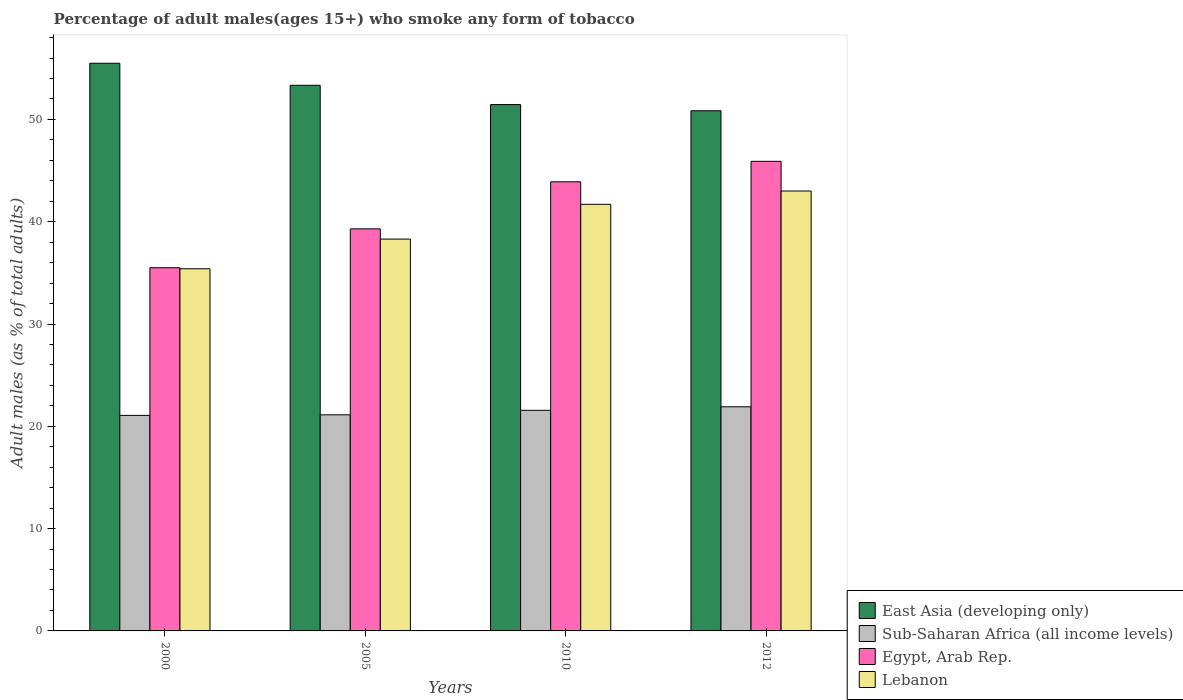How many different coloured bars are there?
Keep it short and to the point. 4. Are the number of bars per tick equal to the number of legend labels?
Offer a very short reply. Yes. How many bars are there on the 2nd tick from the left?
Offer a terse response. 4. How many bars are there on the 1st tick from the right?
Make the answer very short. 4. What is the label of the 4th group of bars from the left?
Make the answer very short. 2012. What is the percentage of adult males who smoke in East Asia (developing only) in 2010?
Provide a succinct answer. 51.45. Across all years, what is the maximum percentage of adult males who smoke in Egypt, Arab Rep.?
Give a very brief answer. 45.9. Across all years, what is the minimum percentage of adult males who smoke in East Asia (developing only)?
Offer a very short reply. 50.84. What is the total percentage of adult males who smoke in Sub-Saharan Africa (all income levels) in the graph?
Give a very brief answer. 85.66. What is the difference between the percentage of adult males who smoke in Egypt, Arab Rep. in 2005 and that in 2012?
Provide a short and direct response. -6.6. What is the difference between the percentage of adult males who smoke in Sub-Saharan Africa (all income levels) in 2010 and the percentage of adult males who smoke in East Asia (developing only) in 2012?
Provide a short and direct response. -29.28. What is the average percentage of adult males who smoke in Sub-Saharan Africa (all income levels) per year?
Provide a short and direct response. 21.42. In the year 2000, what is the difference between the percentage of adult males who smoke in Lebanon and percentage of adult males who smoke in Egypt, Arab Rep.?
Provide a short and direct response. -0.1. In how many years, is the percentage of adult males who smoke in East Asia (developing only) greater than 2 %?
Give a very brief answer. 4. What is the ratio of the percentage of adult males who smoke in Egypt, Arab Rep. in 2010 to that in 2012?
Your answer should be very brief. 0.96. Is the percentage of adult males who smoke in Lebanon in 2000 less than that in 2012?
Keep it short and to the point. Yes. Is the difference between the percentage of adult males who smoke in Lebanon in 2000 and 2012 greater than the difference between the percentage of adult males who smoke in Egypt, Arab Rep. in 2000 and 2012?
Offer a terse response. Yes. What is the difference between the highest and the second highest percentage of adult males who smoke in Egypt, Arab Rep.?
Your answer should be very brief. 2. What is the difference between the highest and the lowest percentage of adult males who smoke in Sub-Saharan Africa (all income levels)?
Your answer should be very brief. 0.84. Is the sum of the percentage of adult males who smoke in Egypt, Arab Rep. in 2000 and 2012 greater than the maximum percentage of adult males who smoke in Lebanon across all years?
Provide a succinct answer. Yes. What does the 1st bar from the left in 2010 represents?
Provide a short and direct response. East Asia (developing only). What does the 3rd bar from the right in 2005 represents?
Keep it short and to the point. Sub-Saharan Africa (all income levels). Is it the case that in every year, the sum of the percentage of adult males who smoke in East Asia (developing only) and percentage of adult males who smoke in Lebanon is greater than the percentage of adult males who smoke in Egypt, Arab Rep.?
Make the answer very short. Yes. Are all the bars in the graph horizontal?
Offer a terse response. No. What is the difference between two consecutive major ticks on the Y-axis?
Give a very brief answer. 10. Does the graph contain any zero values?
Give a very brief answer. No. Does the graph contain grids?
Provide a succinct answer. No. How many legend labels are there?
Offer a very short reply. 4. What is the title of the graph?
Make the answer very short. Percentage of adult males(ages 15+) who smoke any form of tobacco. What is the label or title of the X-axis?
Your response must be concise. Years. What is the label or title of the Y-axis?
Offer a terse response. Adult males (as % of total adults). What is the Adult males (as % of total adults) in East Asia (developing only) in 2000?
Your answer should be compact. 55.49. What is the Adult males (as % of total adults) of Sub-Saharan Africa (all income levels) in 2000?
Your answer should be very brief. 21.07. What is the Adult males (as % of total adults) of Egypt, Arab Rep. in 2000?
Give a very brief answer. 35.5. What is the Adult males (as % of total adults) of Lebanon in 2000?
Keep it short and to the point. 35.4. What is the Adult males (as % of total adults) of East Asia (developing only) in 2005?
Offer a very short reply. 53.33. What is the Adult males (as % of total adults) of Sub-Saharan Africa (all income levels) in 2005?
Make the answer very short. 21.12. What is the Adult males (as % of total adults) of Egypt, Arab Rep. in 2005?
Make the answer very short. 39.3. What is the Adult males (as % of total adults) of Lebanon in 2005?
Keep it short and to the point. 38.3. What is the Adult males (as % of total adults) in East Asia (developing only) in 2010?
Give a very brief answer. 51.45. What is the Adult males (as % of total adults) of Sub-Saharan Africa (all income levels) in 2010?
Make the answer very short. 21.56. What is the Adult males (as % of total adults) of Egypt, Arab Rep. in 2010?
Provide a succinct answer. 43.9. What is the Adult males (as % of total adults) of Lebanon in 2010?
Offer a very short reply. 41.7. What is the Adult males (as % of total adults) in East Asia (developing only) in 2012?
Make the answer very short. 50.84. What is the Adult males (as % of total adults) in Sub-Saharan Africa (all income levels) in 2012?
Offer a very short reply. 21.91. What is the Adult males (as % of total adults) in Egypt, Arab Rep. in 2012?
Your answer should be compact. 45.9. What is the Adult males (as % of total adults) of Lebanon in 2012?
Ensure brevity in your answer.  43. Across all years, what is the maximum Adult males (as % of total adults) in East Asia (developing only)?
Make the answer very short. 55.49. Across all years, what is the maximum Adult males (as % of total adults) in Sub-Saharan Africa (all income levels)?
Offer a terse response. 21.91. Across all years, what is the maximum Adult males (as % of total adults) of Egypt, Arab Rep.?
Make the answer very short. 45.9. Across all years, what is the maximum Adult males (as % of total adults) of Lebanon?
Make the answer very short. 43. Across all years, what is the minimum Adult males (as % of total adults) in East Asia (developing only)?
Offer a very short reply. 50.84. Across all years, what is the minimum Adult males (as % of total adults) of Sub-Saharan Africa (all income levels)?
Provide a short and direct response. 21.07. Across all years, what is the minimum Adult males (as % of total adults) in Egypt, Arab Rep.?
Keep it short and to the point. 35.5. Across all years, what is the minimum Adult males (as % of total adults) in Lebanon?
Ensure brevity in your answer.  35.4. What is the total Adult males (as % of total adults) in East Asia (developing only) in the graph?
Offer a very short reply. 211.11. What is the total Adult males (as % of total adults) of Sub-Saharan Africa (all income levels) in the graph?
Offer a terse response. 85.66. What is the total Adult males (as % of total adults) of Egypt, Arab Rep. in the graph?
Make the answer very short. 164.6. What is the total Adult males (as % of total adults) in Lebanon in the graph?
Give a very brief answer. 158.4. What is the difference between the Adult males (as % of total adults) of East Asia (developing only) in 2000 and that in 2005?
Keep it short and to the point. 2.15. What is the difference between the Adult males (as % of total adults) in Sub-Saharan Africa (all income levels) in 2000 and that in 2005?
Your response must be concise. -0.06. What is the difference between the Adult males (as % of total adults) of Lebanon in 2000 and that in 2005?
Your response must be concise. -2.9. What is the difference between the Adult males (as % of total adults) of East Asia (developing only) in 2000 and that in 2010?
Provide a short and direct response. 4.04. What is the difference between the Adult males (as % of total adults) of Sub-Saharan Africa (all income levels) in 2000 and that in 2010?
Your answer should be compact. -0.5. What is the difference between the Adult males (as % of total adults) in Egypt, Arab Rep. in 2000 and that in 2010?
Provide a short and direct response. -8.4. What is the difference between the Adult males (as % of total adults) of Lebanon in 2000 and that in 2010?
Make the answer very short. -6.3. What is the difference between the Adult males (as % of total adults) of East Asia (developing only) in 2000 and that in 2012?
Ensure brevity in your answer.  4.64. What is the difference between the Adult males (as % of total adults) in Sub-Saharan Africa (all income levels) in 2000 and that in 2012?
Your answer should be very brief. -0.84. What is the difference between the Adult males (as % of total adults) of East Asia (developing only) in 2005 and that in 2010?
Provide a short and direct response. 1.88. What is the difference between the Adult males (as % of total adults) in Sub-Saharan Africa (all income levels) in 2005 and that in 2010?
Offer a very short reply. -0.44. What is the difference between the Adult males (as % of total adults) in Egypt, Arab Rep. in 2005 and that in 2010?
Your answer should be very brief. -4.6. What is the difference between the Adult males (as % of total adults) in Lebanon in 2005 and that in 2010?
Offer a terse response. -3.4. What is the difference between the Adult males (as % of total adults) of East Asia (developing only) in 2005 and that in 2012?
Your answer should be very brief. 2.49. What is the difference between the Adult males (as % of total adults) of Sub-Saharan Africa (all income levels) in 2005 and that in 2012?
Your answer should be very brief. -0.79. What is the difference between the Adult males (as % of total adults) of Egypt, Arab Rep. in 2005 and that in 2012?
Your answer should be very brief. -6.6. What is the difference between the Adult males (as % of total adults) of East Asia (developing only) in 2010 and that in 2012?
Make the answer very short. 0.6. What is the difference between the Adult males (as % of total adults) in Sub-Saharan Africa (all income levels) in 2010 and that in 2012?
Make the answer very short. -0.35. What is the difference between the Adult males (as % of total adults) of Lebanon in 2010 and that in 2012?
Your answer should be compact. -1.3. What is the difference between the Adult males (as % of total adults) in East Asia (developing only) in 2000 and the Adult males (as % of total adults) in Sub-Saharan Africa (all income levels) in 2005?
Offer a very short reply. 34.36. What is the difference between the Adult males (as % of total adults) of East Asia (developing only) in 2000 and the Adult males (as % of total adults) of Egypt, Arab Rep. in 2005?
Make the answer very short. 16.19. What is the difference between the Adult males (as % of total adults) of East Asia (developing only) in 2000 and the Adult males (as % of total adults) of Lebanon in 2005?
Offer a very short reply. 17.19. What is the difference between the Adult males (as % of total adults) of Sub-Saharan Africa (all income levels) in 2000 and the Adult males (as % of total adults) of Egypt, Arab Rep. in 2005?
Offer a very short reply. -18.23. What is the difference between the Adult males (as % of total adults) of Sub-Saharan Africa (all income levels) in 2000 and the Adult males (as % of total adults) of Lebanon in 2005?
Provide a succinct answer. -17.23. What is the difference between the Adult males (as % of total adults) in Egypt, Arab Rep. in 2000 and the Adult males (as % of total adults) in Lebanon in 2005?
Offer a very short reply. -2.8. What is the difference between the Adult males (as % of total adults) of East Asia (developing only) in 2000 and the Adult males (as % of total adults) of Sub-Saharan Africa (all income levels) in 2010?
Offer a very short reply. 33.92. What is the difference between the Adult males (as % of total adults) in East Asia (developing only) in 2000 and the Adult males (as % of total adults) in Egypt, Arab Rep. in 2010?
Your response must be concise. 11.59. What is the difference between the Adult males (as % of total adults) in East Asia (developing only) in 2000 and the Adult males (as % of total adults) in Lebanon in 2010?
Your answer should be very brief. 13.79. What is the difference between the Adult males (as % of total adults) in Sub-Saharan Africa (all income levels) in 2000 and the Adult males (as % of total adults) in Egypt, Arab Rep. in 2010?
Your answer should be compact. -22.83. What is the difference between the Adult males (as % of total adults) of Sub-Saharan Africa (all income levels) in 2000 and the Adult males (as % of total adults) of Lebanon in 2010?
Your response must be concise. -20.63. What is the difference between the Adult males (as % of total adults) in Egypt, Arab Rep. in 2000 and the Adult males (as % of total adults) in Lebanon in 2010?
Offer a very short reply. -6.2. What is the difference between the Adult males (as % of total adults) in East Asia (developing only) in 2000 and the Adult males (as % of total adults) in Sub-Saharan Africa (all income levels) in 2012?
Provide a succinct answer. 33.58. What is the difference between the Adult males (as % of total adults) of East Asia (developing only) in 2000 and the Adult males (as % of total adults) of Egypt, Arab Rep. in 2012?
Make the answer very short. 9.59. What is the difference between the Adult males (as % of total adults) of East Asia (developing only) in 2000 and the Adult males (as % of total adults) of Lebanon in 2012?
Ensure brevity in your answer.  12.49. What is the difference between the Adult males (as % of total adults) of Sub-Saharan Africa (all income levels) in 2000 and the Adult males (as % of total adults) of Egypt, Arab Rep. in 2012?
Your response must be concise. -24.83. What is the difference between the Adult males (as % of total adults) of Sub-Saharan Africa (all income levels) in 2000 and the Adult males (as % of total adults) of Lebanon in 2012?
Give a very brief answer. -21.93. What is the difference between the Adult males (as % of total adults) of East Asia (developing only) in 2005 and the Adult males (as % of total adults) of Sub-Saharan Africa (all income levels) in 2010?
Offer a terse response. 31.77. What is the difference between the Adult males (as % of total adults) in East Asia (developing only) in 2005 and the Adult males (as % of total adults) in Egypt, Arab Rep. in 2010?
Provide a short and direct response. 9.43. What is the difference between the Adult males (as % of total adults) of East Asia (developing only) in 2005 and the Adult males (as % of total adults) of Lebanon in 2010?
Give a very brief answer. 11.63. What is the difference between the Adult males (as % of total adults) in Sub-Saharan Africa (all income levels) in 2005 and the Adult males (as % of total adults) in Egypt, Arab Rep. in 2010?
Your answer should be very brief. -22.78. What is the difference between the Adult males (as % of total adults) of Sub-Saharan Africa (all income levels) in 2005 and the Adult males (as % of total adults) of Lebanon in 2010?
Your response must be concise. -20.58. What is the difference between the Adult males (as % of total adults) in East Asia (developing only) in 2005 and the Adult males (as % of total adults) in Sub-Saharan Africa (all income levels) in 2012?
Your answer should be compact. 31.42. What is the difference between the Adult males (as % of total adults) in East Asia (developing only) in 2005 and the Adult males (as % of total adults) in Egypt, Arab Rep. in 2012?
Ensure brevity in your answer.  7.43. What is the difference between the Adult males (as % of total adults) of East Asia (developing only) in 2005 and the Adult males (as % of total adults) of Lebanon in 2012?
Your response must be concise. 10.33. What is the difference between the Adult males (as % of total adults) in Sub-Saharan Africa (all income levels) in 2005 and the Adult males (as % of total adults) in Egypt, Arab Rep. in 2012?
Give a very brief answer. -24.78. What is the difference between the Adult males (as % of total adults) of Sub-Saharan Africa (all income levels) in 2005 and the Adult males (as % of total adults) of Lebanon in 2012?
Your response must be concise. -21.88. What is the difference between the Adult males (as % of total adults) in Egypt, Arab Rep. in 2005 and the Adult males (as % of total adults) in Lebanon in 2012?
Make the answer very short. -3.7. What is the difference between the Adult males (as % of total adults) in East Asia (developing only) in 2010 and the Adult males (as % of total adults) in Sub-Saharan Africa (all income levels) in 2012?
Provide a short and direct response. 29.54. What is the difference between the Adult males (as % of total adults) of East Asia (developing only) in 2010 and the Adult males (as % of total adults) of Egypt, Arab Rep. in 2012?
Your answer should be compact. 5.55. What is the difference between the Adult males (as % of total adults) of East Asia (developing only) in 2010 and the Adult males (as % of total adults) of Lebanon in 2012?
Offer a very short reply. 8.45. What is the difference between the Adult males (as % of total adults) in Sub-Saharan Africa (all income levels) in 2010 and the Adult males (as % of total adults) in Egypt, Arab Rep. in 2012?
Provide a short and direct response. -24.34. What is the difference between the Adult males (as % of total adults) of Sub-Saharan Africa (all income levels) in 2010 and the Adult males (as % of total adults) of Lebanon in 2012?
Your answer should be compact. -21.44. What is the difference between the Adult males (as % of total adults) of Egypt, Arab Rep. in 2010 and the Adult males (as % of total adults) of Lebanon in 2012?
Your response must be concise. 0.9. What is the average Adult males (as % of total adults) in East Asia (developing only) per year?
Your answer should be compact. 52.78. What is the average Adult males (as % of total adults) in Sub-Saharan Africa (all income levels) per year?
Provide a short and direct response. 21.42. What is the average Adult males (as % of total adults) of Egypt, Arab Rep. per year?
Give a very brief answer. 41.15. What is the average Adult males (as % of total adults) of Lebanon per year?
Offer a terse response. 39.6. In the year 2000, what is the difference between the Adult males (as % of total adults) in East Asia (developing only) and Adult males (as % of total adults) in Sub-Saharan Africa (all income levels)?
Give a very brief answer. 34.42. In the year 2000, what is the difference between the Adult males (as % of total adults) of East Asia (developing only) and Adult males (as % of total adults) of Egypt, Arab Rep.?
Provide a succinct answer. 19.99. In the year 2000, what is the difference between the Adult males (as % of total adults) of East Asia (developing only) and Adult males (as % of total adults) of Lebanon?
Offer a terse response. 20.09. In the year 2000, what is the difference between the Adult males (as % of total adults) of Sub-Saharan Africa (all income levels) and Adult males (as % of total adults) of Egypt, Arab Rep.?
Offer a terse response. -14.43. In the year 2000, what is the difference between the Adult males (as % of total adults) in Sub-Saharan Africa (all income levels) and Adult males (as % of total adults) in Lebanon?
Make the answer very short. -14.33. In the year 2005, what is the difference between the Adult males (as % of total adults) of East Asia (developing only) and Adult males (as % of total adults) of Sub-Saharan Africa (all income levels)?
Offer a very short reply. 32.21. In the year 2005, what is the difference between the Adult males (as % of total adults) in East Asia (developing only) and Adult males (as % of total adults) in Egypt, Arab Rep.?
Offer a very short reply. 14.03. In the year 2005, what is the difference between the Adult males (as % of total adults) of East Asia (developing only) and Adult males (as % of total adults) of Lebanon?
Give a very brief answer. 15.03. In the year 2005, what is the difference between the Adult males (as % of total adults) of Sub-Saharan Africa (all income levels) and Adult males (as % of total adults) of Egypt, Arab Rep.?
Your answer should be compact. -18.18. In the year 2005, what is the difference between the Adult males (as % of total adults) in Sub-Saharan Africa (all income levels) and Adult males (as % of total adults) in Lebanon?
Your response must be concise. -17.18. In the year 2010, what is the difference between the Adult males (as % of total adults) in East Asia (developing only) and Adult males (as % of total adults) in Sub-Saharan Africa (all income levels)?
Keep it short and to the point. 29.88. In the year 2010, what is the difference between the Adult males (as % of total adults) in East Asia (developing only) and Adult males (as % of total adults) in Egypt, Arab Rep.?
Give a very brief answer. 7.55. In the year 2010, what is the difference between the Adult males (as % of total adults) in East Asia (developing only) and Adult males (as % of total adults) in Lebanon?
Offer a terse response. 9.75. In the year 2010, what is the difference between the Adult males (as % of total adults) in Sub-Saharan Africa (all income levels) and Adult males (as % of total adults) in Egypt, Arab Rep.?
Make the answer very short. -22.34. In the year 2010, what is the difference between the Adult males (as % of total adults) in Sub-Saharan Africa (all income levels) and Adult males (as % of total adults) in Lebanon?
Make the answer very short. -20.14. In the year 2010, what is the difference between the Adult males (as % of total adults) of Egypt, Arab Rep. and Adult males (as % of total adults) of Lebanon?
Provide a succinct answer. 2.2. In the year 2012, what is the difference between the Adult males (as % of total adults) in East Asia (developing only) and Adult males (as % of total adults) in Sub-Saharan Africa (all income levels)?
Give a very brief answer. 28.93. In the year 2012, what is the difference between the Adult males (as % of total adults) of East Asia (developing only) and Adult males (as % of total adults) of Egypt, Arab Rep.?
Provide a succinct answer. 4.94. In the year 2012, what is the difference between the Adult males (as % of total adults) of East Asia (developing only) and Adult males (as % of total adults) of Lebanon?
Offer a terse response. 7.84. In the year 2012, what is the difference between the Adult males (as % of total adults) of Sub-Saharan Africa (all income levels) and Adult males (as % of total adults) of Egypt, Arab Rep.?
Give a very brief answer. -23.99. In the year 2012, what is the difference between the Adult males (as % of total adults) in Sub-Saharan Africa (all income levels) and Adult males (as % of total adults) in Lebanon?
Your response must be concise. -21.09. What is the ratio of the Adult males (as % of total adults) of East Asia (developing only) in 2000 to that in 2005?
Keep it short and to the point. 1.04. What is the ratio of the Adult males (as % of total adults) of Sub-Saharan Africa (all income levels) in 2000 to that in 2005?
Ensure brevity in your answer.  1. What is the ratio of the Adult males (as % of total adults) of Egypt, Arab Rep. in 2000 to that in 2005?
Make the answer very short. 0.9. What is the ratio of the Adult males (as % of total adults) in Lebanon in 2000 to that in 2005?
Your answer should be compact. 0.92. What is the ratio of the Adult males (as % of total adults) in East Asia (developing only) in 2000 to that in 2010?
Give a very brief answer. 1.08. What is the ratio of the Adult males (as % of total adults) in Sub-Saharan Africa (all income levels) in 2000 to that in 2010?
Your answer should be very brief. 0.98. What is the ratio of the Adult males (as % of total adults) in Egypt, Arab Rep. in 2000 to that in 2010?
Give a very brief answer. 0.81. What is the ratio of the Adult males (as % of total adults) in Lebanon in 2000 to that in 2010?
Provide a short and direct response. 0.85. What is the ratio of the Adult males (as % of total adults) of East Asia (developing only) in 2000 to that in 2012?
Your answer should be compact. 1.09. What is the ratio of the Adult males (as % of total adults) of Sub-Saharan Africa (all income levels) in 2000 to that in 2012?
Offer a terse response. 0.96. What is the ratio of the Adult males (as % of total adults) of Egypt, Arab Rep. in 2000 to that in 2012?
Provide a short and direct response. 0.77. What is the ratio of the Adult males (as % of total adults) of Lebanon in 2000 to that in 2012?
Your response must be concise. 0.82. What is the ratio of the Adult males (as % of total adults) of East Asia (developing only) in 2005 to that in 2010?
Give a very brief answer. 1.04. What is the ratio of the Adult males (as % of total adults) of Sub-Saharan Africa (all income levels) in 2005 to that in 2010?
Provide a short and direct response. 0.98. What is the ratio of the Adult males (as % of total adults) of Egypt, Arab Rep. in 2005 to that in 2010?
Provide a short and direct response. 0.9. What is the ratio of the Adult males (as % of total adults) of Lebanon in 2005 to that in 2010?
Provide a succinct answer. 0.92. What is the ratio of the Adult males (as % of total adults) in East Asia (developing only) in 2005 to that in 2012?
Provide a succinct answer. 1.05. What is the ratio of the Adult males (as % of total adults) in Sub-Saharan Africa (all income levels) in 2005 to that in 2012?
Ensure brevity in your answer.  0.96. What is the ratio of the Adult males (as % of total adults) of Egypt, Arab Rep. in 2005 to that in 2012?
Give a very brief answer. 0.86. What is the ratio of the Adult males (as % of total adults) in Lebanon in 2005 to that in 2012?
Provide a short and direct response. 0.89. What is the ratio of the Adult males (as % of total adults) of East Asia (developing only) in 2010 to that in 2012?
Offer a terse response. 1.01. What is the ratio of the Adult males (as % of total adults) in Sub-Saharan Africa (all income levels) in 2010 to that in 2012?
Offer a terse response. 0.98. What is the ratio of the Adult males (as % of total adults) in Egypt, Arab Rep. in 2010 to that in 2012?
Provide a short and direct response. 0.96. What is the ratio of the Adult males (as % of total adults) in Lebanon in 2010 to that in 2012?
Your response must be concise. 0.97. What is the difference between the highest and the second highest Adult males (as % of total adults) of East Asia (developing only)?
Offer a terse response. 2.15. What is the difference between the highest and the second highest Adult males (as % of total adults) of Sub-Saharan Africa (all income levels)?
Ensure brevity in your answer.  0.35. What is the difference between the highest and the second highest Adult males (as % of total adults) of Egypt, Arab Rep.?
Keep it short and to the point. 2. What is the difference between the highest and the lowest Adult males (as % of total adults) in East Asia (developing only)?
Keep it short and to the point. 4.64. What is the difference between the highest and the lowest Adult males (as % of total adults) in Sub-Saharan Africa (all income levels)?
Provide a succinct answer. 0.84. What is the difference between the highest and the lowest Adult males (as % of total adults) of Egypt, Arab Rep.?
Your answer should be very brief. 10.4. What is the difference between the highest and the lowest Adult males (as % of total adults) in Lebanon?
Offer a very short reply. 7.6. 